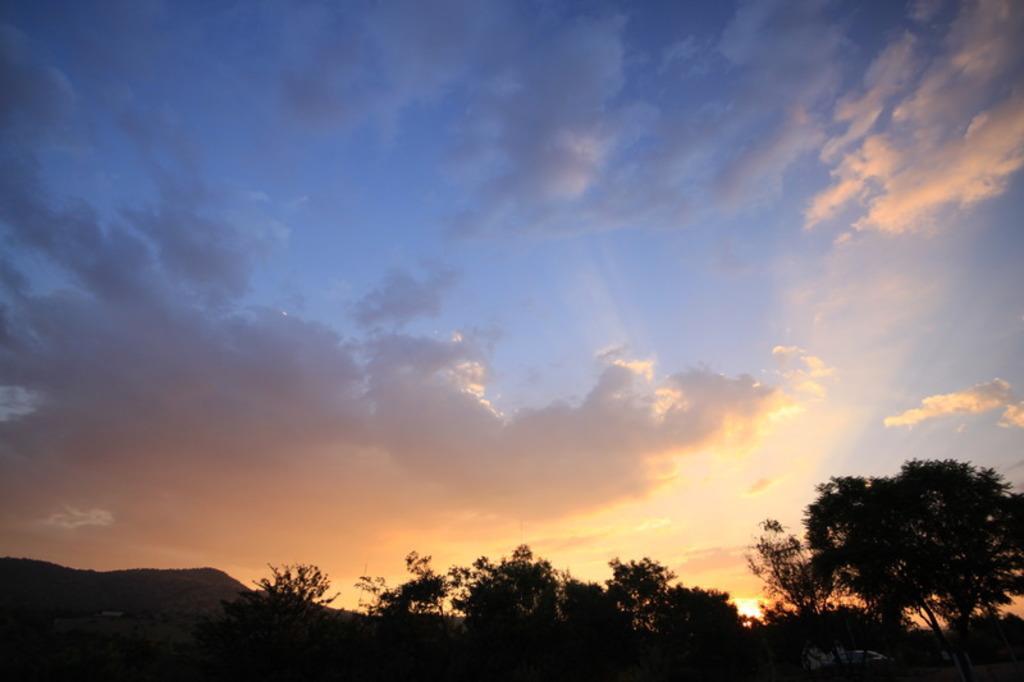How would you summarize this image in a sentence or two? In this image, we can see a cloudy sky. At the bottom of the image, we can see trees, hill. 